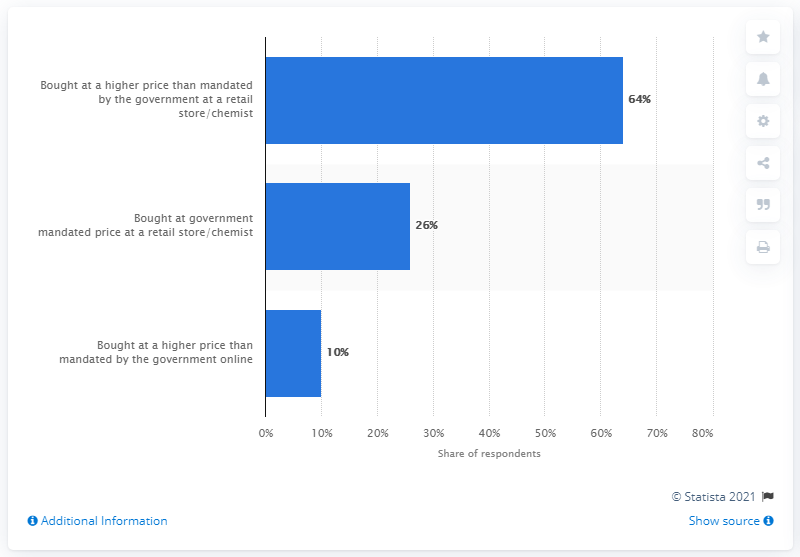Identify some key points in this picture. The value of 54 in the chart represents a difference between high and low values. 